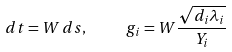Convert formula to latex. <formula><loc_0><loc_0><loc_500><loc_500>d t = W \, d s , \quad \ { g } _ { i } = W \frac { \sqrt { d _ { i } \lambda _ { i } } } { Y _ { i } } \,</formula> 